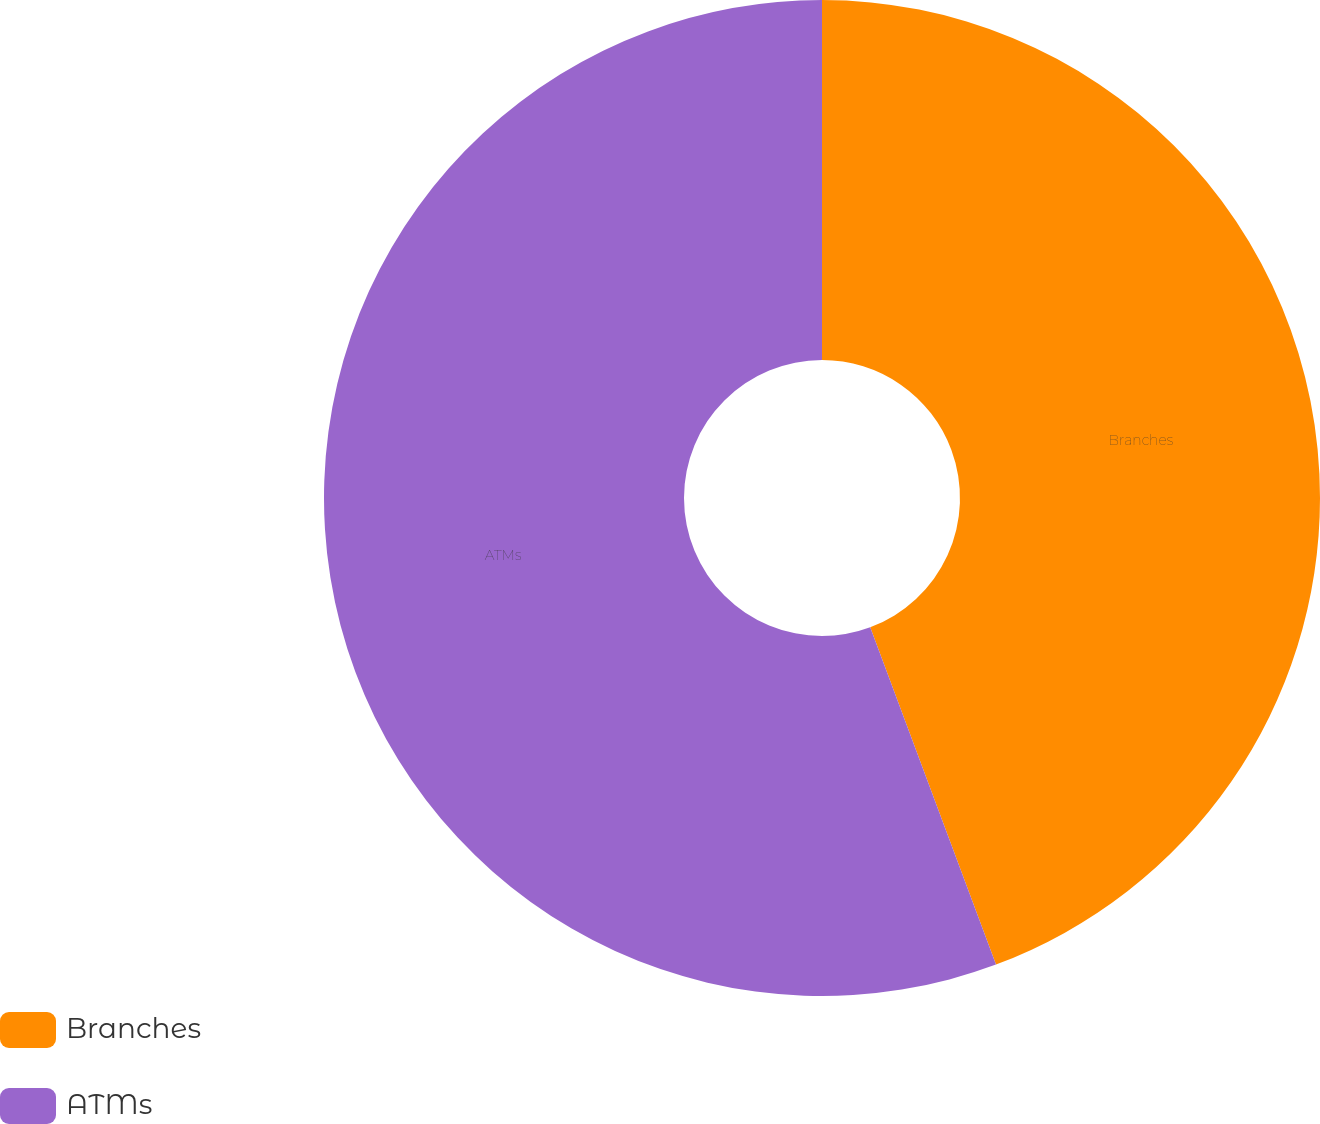<chart> <loc_0><loc_0><loc_500><loc_500><pie_chart><fcel>Branches<fcel>ATMs<nl><fcel>44.32%<fcel>55.68%<nl></chart> 